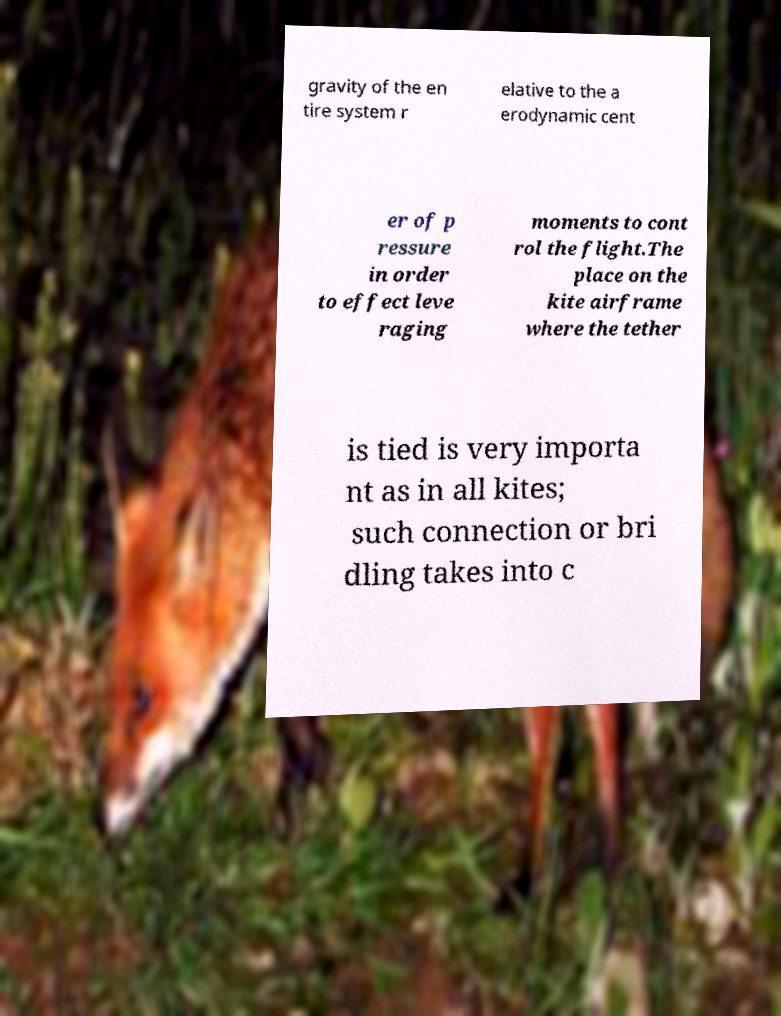Can you accurately transcribe the text from the provided image for me? gravity of the en tire system r elative to the a erodynamic cent er of p ressure in order to effect leve raging moments to cont rol the flight.The place on the kite airframe where the tether is tied is very importa nt as in all kites; such connection or bri dling takes into c 